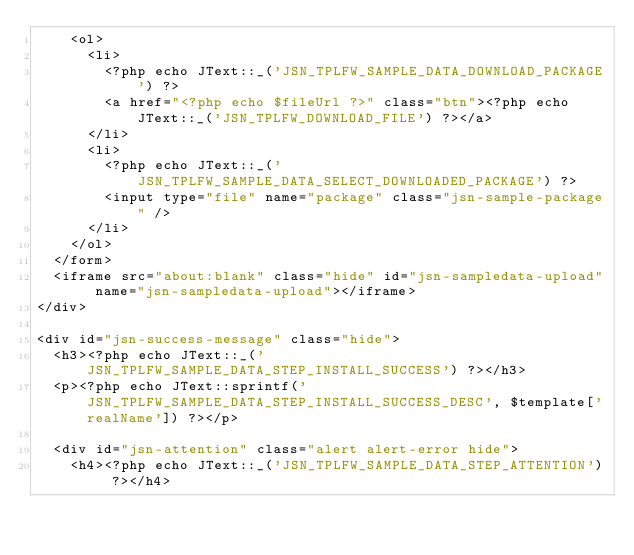Convert code to text. <code><loc_0><loc_0><loc_500><loc_500><_PHP_>		<ol>
			<li>
				<?php echo JText::_('JSN_TPLFW_SAMPLE_DATA_DOWNLOAD_PACKAGE') ?>
				<a href="<?php echo $fileUrl ?>" class="btn"><?php echo JText::_('JSN_TPLFW_DOWNLOAD_FILE') ?></a>
			</li>
			<li>
				<?php echo JText::_('JSN_TPLFW_SAMPLE_DATA_SELECT_DOWNLOADED_PACKAGE') ?>
				<input type="file" name="package" class="jsn-sample-package" />
			</li>
		</ol>
	</form>
	<iframe src="about:blank" class="hide" id="jsn-sampledata-upload" name="jsn-sampledata-upload"></iframe>
</div>

<div id="jsn-success-message" class="hide">
	<h3><?php echo JText::_('JSN_TPLFW_SAMPLE_DATA_STEP_INSTALL_SUCCESS') ?></h3>
	<p><?php echo JText::sprintf('JSN_TPLFW_SAMPLE_DATA_STEP_INSTALL_SUCCESS_DESC', $template['realName']) ?></p>

	<div id="jsn-attention" class="alert alert-error hide">
		<h4><?php echo JText::_('JSN_TPLFW_SAMPLE_DATA_STEP_ATTENTION') ?></h4></code> 